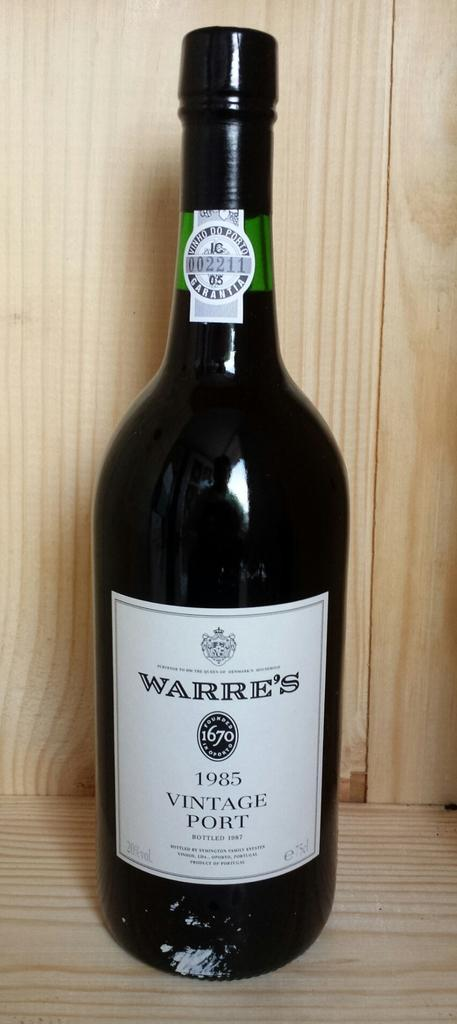<image>
Render a clear and concise summary of the photo. A bottle of Warre's 1985 Vintage Port sits on a wood display. 